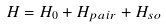Convert formula to latex. <formula><loc_0><loc_0><loc_500><loc_500>H = H _ { 0 } + H _ { p a i r } + H _ { s o }</formula> 